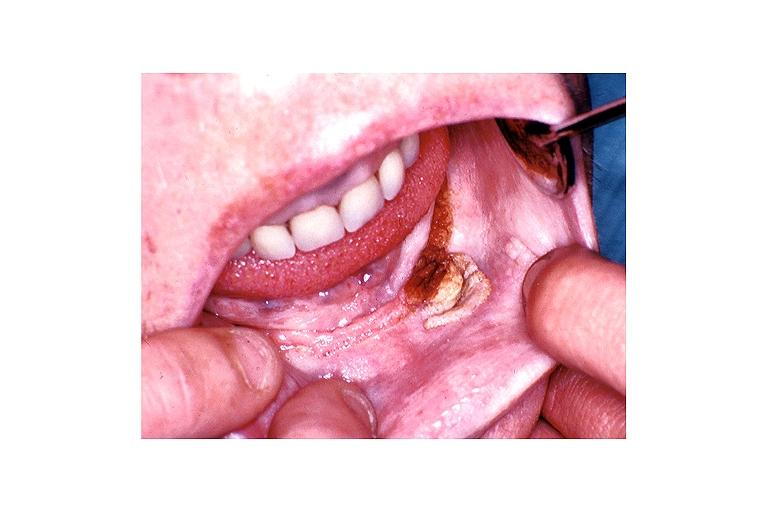where is this?
Answer the question using a single word or phrase. Oral 